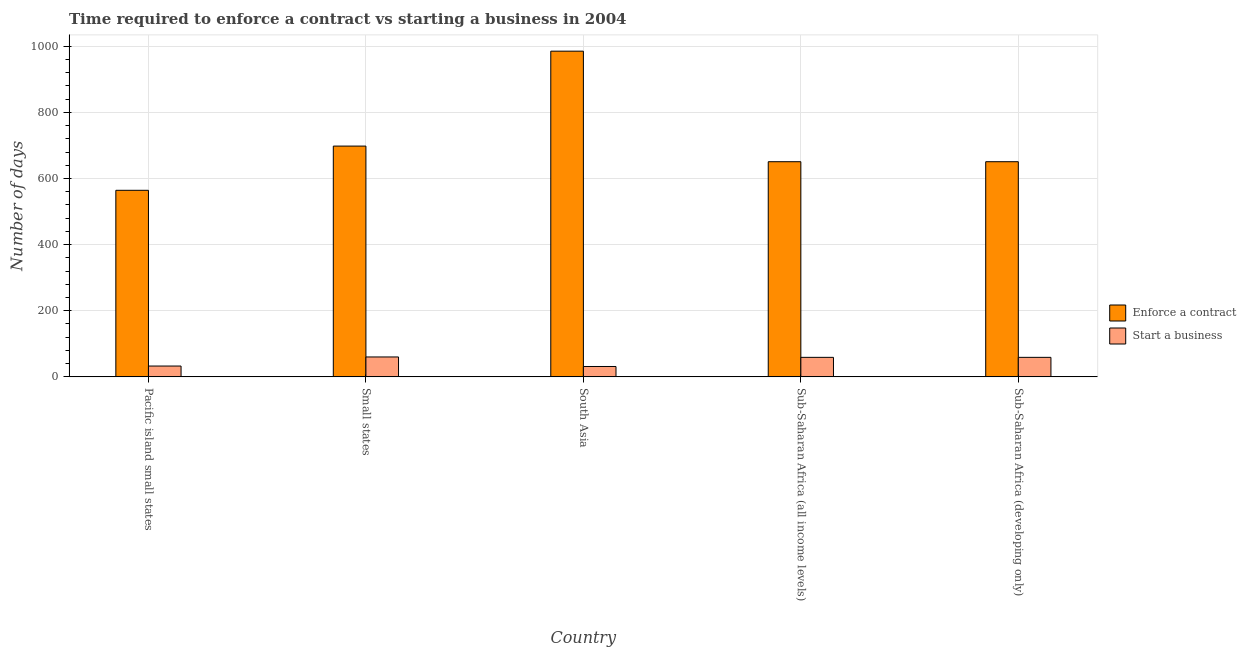Are the number of bars on each tick of the X-axis equal?
Make the answer very short. Yes. How many bars are there on the 5th tick from the left?
Provide a short and direct response. 2. How many bars are there on the 2nd tick from the right?
Your response must be concise. 2. What is the label of the 1st group of bars from the left?
Your response must be concise. Pacific island small states. What is the number of days to start a business in Pacific island small states?
Provide a short and direct response. 32.78. Across all countries, what is the maximum number of days to enforece a contract?
Offer a terse response. 985. Across all countries, what is the minimum number of days to start a business?
Your answer should be compact. 31.4. In which country was the number of days to enforece a contract minimum?
Offer a terse response. Pacific island small states. What is the total number of days to start a business in the graph?
Keep it short and to the point. 242.44. What is the difference between the number of days to start a business in Pacific island small states and that in Small states?
Make the answer very short. -27.43. What is the difference between the number of days to enforece a contract in Sub-Saharan Africa (all income levels) and the number of days to start a business in Pacific island small states?
Keep it short and to the point. 617.89. What is the average number of days to start a business per country?
Your answer should be compact. 48.49. What is the difference between the number of days to enforece a contract and number of days to start a business in Sub-Saharan Africa (developing only)?
Your answer should be compact. 591.64. In how many countries, is the number of days to enforece a contract greater than 600 days?
Offer a terse response. 4. What is the ratio of the number of days to start a business in South Asia to that in Sub-Saharan Africa (all income levels)?
Make the answer very short. 0.53. Is the difference between the number of days to enforece a contract in Small states and Sub-Saharan Africa (developing only) greater than the difference between the number of days to start a business in Small states and Sub-Saharan Africa (developing only)?
Offer a very short reply. Yes. What is the difference between the highest and the second highest number of days to enforece a contract?
Provide a short and direct response. 287.05. What is the difference between the highest and the lowest number of days to start a business?
Offer a very short reply. 28.81. In how many countries, is the number of days to start a business greater than the average number of days to start a business taken over all countries?
Keep it short and to the point. 3. What does the 1st bar from the left in Sub-Saharan Africa (developing only) represents?
Keep it short and to the point. Enforce a contract. What does the 1st bar from the right in South Asia represents?
Keep it short and to the point. Start a business. How many bars are there?
Provide a short and direct response. 10. How many countries are there in the graph?
Give a very brief answer. 5. Are the values on the major ticks of Y-axis written in scientific E-notation?
Make the answer very short. No. Does the graph contain grids?
Offer a terse response. Yes. What is the title of the graph?
Provide a succinct answer. Time required to enforce a contract vs starting a business in 2004. Does "Commercial bank branches" appear as one of the legend labels in the graph?
Offer a terse response. No. What is the label or title of the Y-axis?
Make the answer very short. Number of days. What is the Number of days in Enforce a contract in Pacific island small states?
Ensure brevity in your answer.  564.22. What is the Number of days of Start a business in Pacific island small states?
Make the answer very short. 32.78. What is the Number of days of Enforce a contract in Small states?
Your response must be concise. 697.95. What is the Number of days of Start a business in Small states?
Keep it short and to the point. 60.21. What is the Number of days of Enforce a contract in South Asia?
Offer a terse response. 985. What is the Number of days in Start a business in South Asia?
Offer a very short reply. 31.4. What is the Number of days of Enforce a contract in Sub-Saharan Africa (all income levels)?
Keep it short and to the point. 650.67. What is the Number of days in Start a business in Sub-Saharan Africa (all income levels)?
Your response must be concise. 59.03. What is the Number of days of Enforce a contract in Sub-Saharan Africa (developing only)?
Keep it short and to the point. 650.67. What is the Number of days of Start a business in Sub-Saharan Africa (developing only)?
Ensure brevity in your answer.  59.03. Across all countries, what is the maximum Number of days in Enforce a contract?
Offer a terse response. 985. Across all countries, what is the maximum Number of days in Start a business?
Your answer should be very brief. 60.21. Across all countries, what is the minimum Number of days of Enforce a contract?
Offer a terse response. 564.22. Across all countries, what is the minimum Number of days of Start a business?
Make the answer very short. 31.4. What is the total Number of days of Enforce a contract in the graph?
Make the answer very short. 3548.5. What is the total Number of days of Start a business in the graph?
Offer a terse response. 242.44. What is the difference between the Number of days in Enforce a contract in Pacific island small states and that in Small states?
Offer a very short reply. -133.73. What is the difference between the Number of days in Start a business in Pacific island small states and that in Small states?
Provide a short and direct response. -27.43. What is the difference between the Number of days in Enforce a contract in Pacific island small states and that in South Asia?
Your answer should be compact. -420.78. What is the difference between the Number of days in Start a business in Pacific island small states and that in South Asia?
Your answer should be compact. 1.38. What is the difference between the Number of days of Enforce a contract in Pacific island small states and that in Sub-Saharan Africa (all income levels)?
Offer a terse response. -86.44. What is the difference between the Number of days of Start a business in Pacific island small states and that in Sub-Saharan Africa (all income levels)?
Provide a short and direct response. -26.25. What is the difference between the Number of days of Enforce a contract in Pacific island small states and that in Sub-Saharan Africa (developing only)?
Provide a succinct answer. -86.44. What is the difference between the Number of days in Start a business in Pacific island small states and that in Sub-Saharan Africa (developing only)?
Provide a succinct answer. -26.25. What is the difference between the Number of days of Enforce a contract in Small states and that in South Asia?
Your response must be concise. -287.05. What is the difference between the Number of days of Start a business in Small states and that in South Asia?
Your answer should be compact. 28.81. What is the difference between the Number of days of Enforce a contract in Small states and that in Sub-Saharan Africa (all income levels)?
Give a very brief answer. 47.28. What is the difference between the Number of days of Start a business in Small states and that in Sub-Saharan Africa (all income levels)?
Ensure brevity in your answer.  1.18. What is the difference between the Number of days of Enforce a contract in Small states and that in Sub-Saharan Africa (developing only)?
Provide a short and direct response. 47.28. What is the difference between the Number of days in Start a business in Small states and that in Sub-Saharan Africa (developing only)?
Keep it short and to the point. 1.18. What is the difference between the Number of days of Enforce a contract in South Asia and that in Sub-Saharan Africa (all income levels)?
Ensure brevity in your answer.  334.33. What is the difference between the Number of days in Start a business in South Asia and that in Sub-Saharan Africa (all income levels)?
Give a very brief answer. -27.63. What is the difference between the Number of days in Enforce a contract in South Asia and that in Sub-Saharan Africa (developing only)?
Offer a very short reply. 334.33. What is the difference between the Number of days in Start a business in South Asia and that in Sub-Saharan Africa (developing only)?
Your response must be concise. -27.63. What is the difference between the Number of days of Enforce a contract in Sub-Saharan Africa (all income levels) and that in Sub-Saharan Africa (developing only)?
Ensure brevity in your answer.  0. What is the difference between the Number of days of Enforce a contract in Pacific island small states and the Number of days of Start a business in Small states?
Keep it short and to the point. 504.01. What is the difference between the Number of days of Enforce a contract in Pacific island small states and the Number of days of Start a business in South Asia?
Your answer should be compact. 532.82. What is the difference between the Number of days in Enforce a contract in Pacific island small states and the Number of days in Start a business in Sub-Saharan Africa (all income levels)?
Provide a short and direct response. 505.19. What is the difference between the Number of days in Enforce a contract in Pacific island small states and the Number of days in Start a business in Sub-Saharan Africa (developing only)?
Give a very brief answer. 505.19. What is the difference between the Number of days of Enforce a contract in Small states and the Number of days of Start a business in South Asia?
Your answer should be very brief. 666.55. What is the difference between the Number of days of Enforce a contract in Small states and the Number of days of Start a business in Sub-Saharan Africa (all income levels)?
Your answer should be very brief. 638.92. What is the difference between the Number of days of Enforce a contract in Small states and the Number of days of Start a business in Sub-Saharan Africa (developing only)?
Your answer should be very brief. 638.92. What is the difference between the Number of days in Enforce a contract in South Asia and the Number of days in Start a business in Sub-Saharan Africa (all income levels)?
Your response must be concise. 925.97. What is the difference between the Number of days in Enforce a contract in South Asia and the Number of days in Start a business in Sub-Saharan Africa (developing only)?
Your response must be concise. 925.97. What is the difference between the Number of days in Enforce a contract in Sub-Saharan Africa (all income levels) and the Number of days in Start a business in Sub-Saharan Africa (developing only)?
Your response must be concise. 591.64. What is the average Number of days of Enforce a contract per country?
Make the answer very short. 709.7. What is the average Number of days of Start a business per country?
Your answer should be very brief. 48.49. What is the difference between the Number of days of Enforce a contract and Number of days of Start a business in Pacific island small states?
Give a very brief answer. 531.44. What is the difference between the Number of days of Enforce a contract and Number of days of Start a business in Small states?
Your answer should be compact. 637.74. What is the difference between the Number of days of Enforce a contract and Number of days of Start a business in South Asia?
Provide a short and direct response. 953.6. What is the difference between the Number of days of Enforce a contract and Number of days of Start a business in Sub-Saharan Africa (all income levels)?
Provide a short and direct response. 591.64. What is the difference between the Number of days in Enforce a contract and Number of days in Start a business in Sub-Saharan Africa (developing only)?
Give a very brief answer. 591.64. What is the ratio of the Number of days in Enforce a contract in Pacific island small states to that in Small states?
Offer a terse response. 0.81. What is the ratio of the Number of days of Start a business in Pacific island small states to that in Small states?
Provide a short and direct response. 0.54. What is the ratio of the Number of days in Enforce a contract in Pacific island small states to that in South Asia?
Provide a short and direct response. 0.57. What is the ratio of the Number of days of Start a business in Pacific island small states to that in South Asia?
Make the answer very short. 1.04. What is the ratio of the Number of days in Enforce a contract in Pacific island small states to that in Sub-Saharan Africa (all income levels)?
Ensure brevity in your answer.  0.87. What is the ratio of the Number of days in Start a business in Pacific island small states to that in Sub-Saharan Africa (all income levels)?
Ensure brevity in your answer.  0.56. What is the ratio of the Number of days in Enforce a contract in Pacific island small states to that in Sub-Saharan Africa (developing only)?
Your answer should be very brief. 0.87. What is the ratio of the Number of days of Start a business in Pacific island small states to that in Sub-Saharan Africa (developing only)?
Offer a terse response. 0.56. What is the ratio of the Number of days of Enforce a contract in Small states to that in South Asia?
Your response must be concise. 0.71. What is the ratio of the Number of days of Start a business in Small states to that in South Asia?
Provide a short and direct response. 1.92. What is the ratio of the Number of days in Enforce a contract in Small states to that in Sub-Saharan Africa (all income levels)?
Your answer should be very brief. 1.07. What is the ratio of the Number of days in Start a business in Small states to that in Sub-Saharan Africa (all income levels)?
Offer a very short reply. 1.02. What is the ratio of the Number of days of Enforce a contract in Small states to that in Sub-Saharan Africa (developing only)?
Ensure brevity in your answer.  1.07. What is the ratio of the Number of days of Start a business in Small states to that in Sub-Saharan Africa (developing only)?
Make the answer very short. 1.02. What is the ratio of the Number of days in Enforce a contract in South Asia to that in Sub-Saharan Africa (all income levels)?
Your answer should be very brief. 1.51. What is the ratio of the Number of days of Start a business in South Asia to that in Sub-Saharan Africa (all income levels)?
Make the answer very short. 0.53. What is the ratio of the Number of days of Enforce a contract in South Asia to that in Sub-Saharan Africa (developing only)?
Make the answer very short. 1.51. What is the ratio of the Number of days in Start a business in South Asia to that in Sub-Saharan Africa (developing only)?
Offer a very short reply. 0.53. What is the ratio of the Number of days in Start a business in Sub-Saharan Africa (all income levels) to that in Sub-Saharan Africa (developing only)?
Make the answer very short. 1. What is the difference between the highest and the second highest Number of days of Enforce a contract?
Your answer should be compact. 287.05. What is the difference between the highest and the second highest Number of days in Start a business?
Provide a short and direct response. 1.18. What is the difference between the highest and the lowest Number of days of Enforce a contract?
Your answer should be very brief. 420.78. What is the difference between the highest and the lowest Number of days of Start a business?
Make the answer very short. 28.81. 